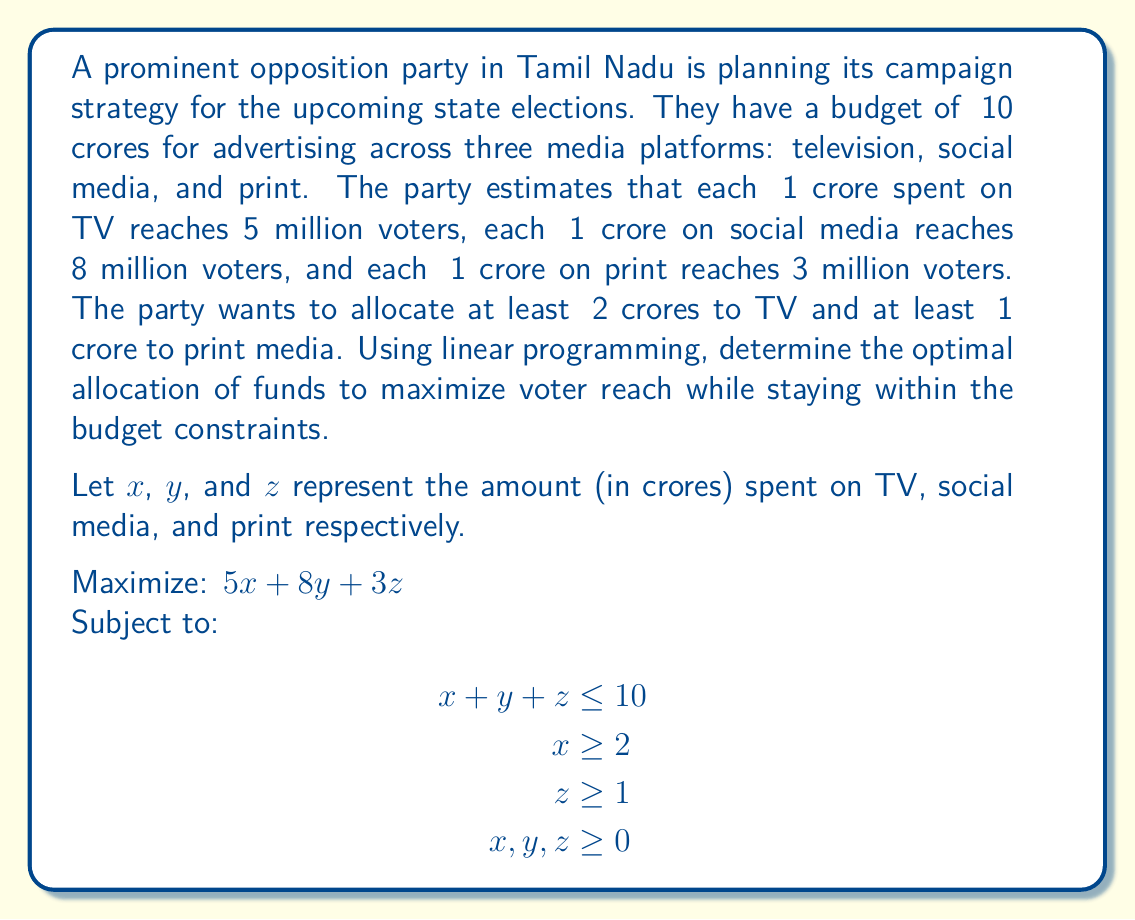Provide a solution to this math problem. To solve this linear programming problem, we'll use the simplex method:

1) First, convert the inequalities to equations by introducing slack variables:
   $x + y + z + s_1 = 10$
   $x - s_2 = 2$
   $z - s_3 = 1$

2) Initial tableau:
   $$
   \begin{array}{c|cccccccc}
    & x & y & z & s_1 & s_2 & s_3 & RHS \\
   \hline
   0 & 5 & 8 & 3 & 0 & 0 & 0 & 0 \\
   s_1 & 1 & 1 & 1 & 1 & 0 & 0 & 10 \\
   x & 1 & 0 & 0 & 0 & -1 & 0 & 2 \\
   z & 0 & 0 & 1 & 0 & 0 & -1 & 1 \\
   \end{array}
   $$

3) The most positive coefficient in the objective row is 8 (column y), so y enters the basis.

4) After pivoting:
   $$
   \begin{array}{c|cccccccc}
    & x & y & z & s_1 & s_2 & s_3 & RHS \\
   \hline
   0 & -3 & 0 & -5 & -8 & 0 & 0 & -80 \\
   y & 1 & 1 & 1 & 1 & 0 & 0 & 10 \\
   x & 1 & 0 & 0 & 0 & -1 & 0 & 2 \\
   z & 0 & 0 & 1 & 0 & 0 & -1 & 1 \\
   \end{array}
   $$

5) The most negative coefficient in the objective row is -5 (column z), so z enters the basis.

6) After pivoting:
   $$
   \begin{array}{c|cccccccc}
    & x & y & z & s_1 & s_2 & s_3 & RHS \\
   \hline
   0 & -3 & 0 & 0 & -8 & 0 & 5 & -75 \\
   y & 1 & 1 & 0 & 1 & 0 & -1 & 9 \\
   x & 1 & 0 & 0 & 0 & -1 & 0 & 2 \\
   z & 0 & 0 & 1 & 0 & 0 & -1 & 1 \\
   \end{array}
   $$

7) All coefficients in the objective row are non-positive, so we've reached the optimal solution.

8) Reading the solution:
   $x = 2$ (TV advertising)
   $y = 9$ (Social media advertising)
   $z = 1$ (Print advertising)

9) The maximum voter reach is: $5(2) + 8(9) + 3(1) = 85$ million voters
Answer: TV: ₹2 crores, Social Media: ₹9 crores, Print: ₹1 crore; Maximum reach: 85 million voters 